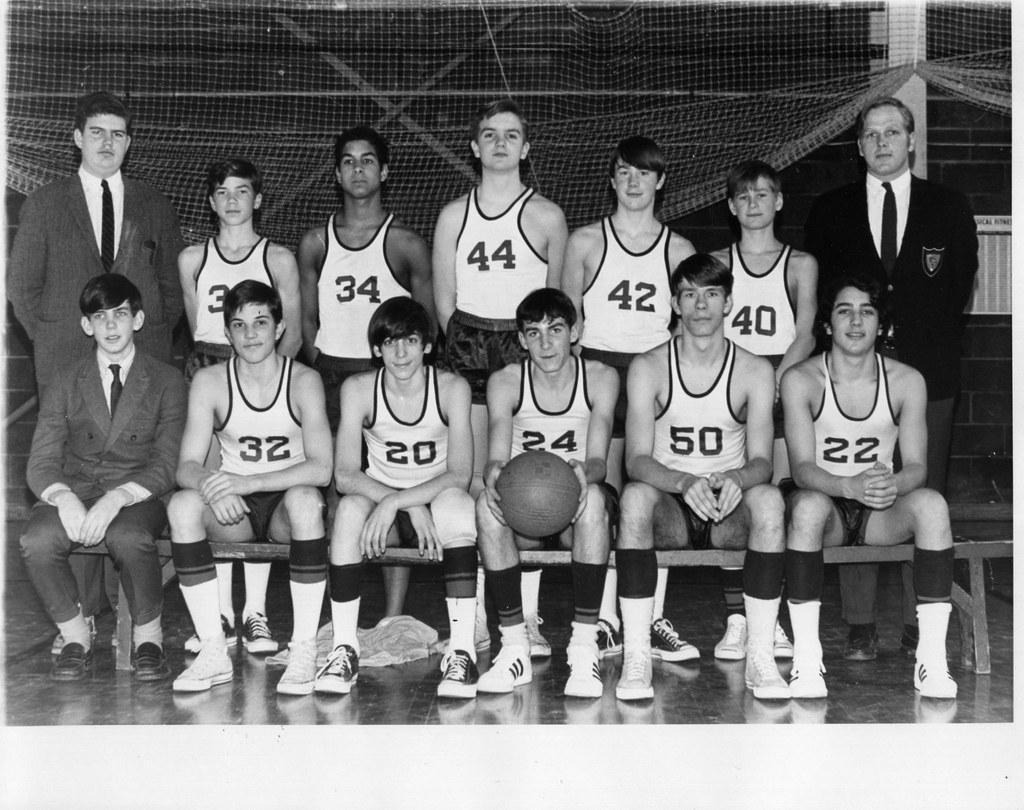Can you describe this image briefly? This image consists of many people. They are wearing jerseys. In the front, the boy is holding a ball. At the bottom, there is a floor. In the background, we can see a net. 